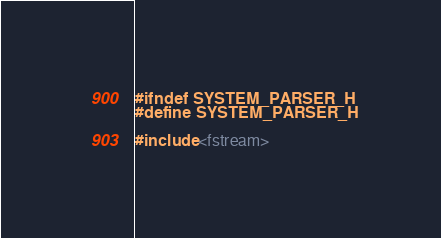Convert code to text. <code><loc_0><loc_0><loc_500><loc_500><_C_>#ifndef SYSTEM_PARSER_H
#define SYSTEM_PARSER_H

#include <fstream></code> 